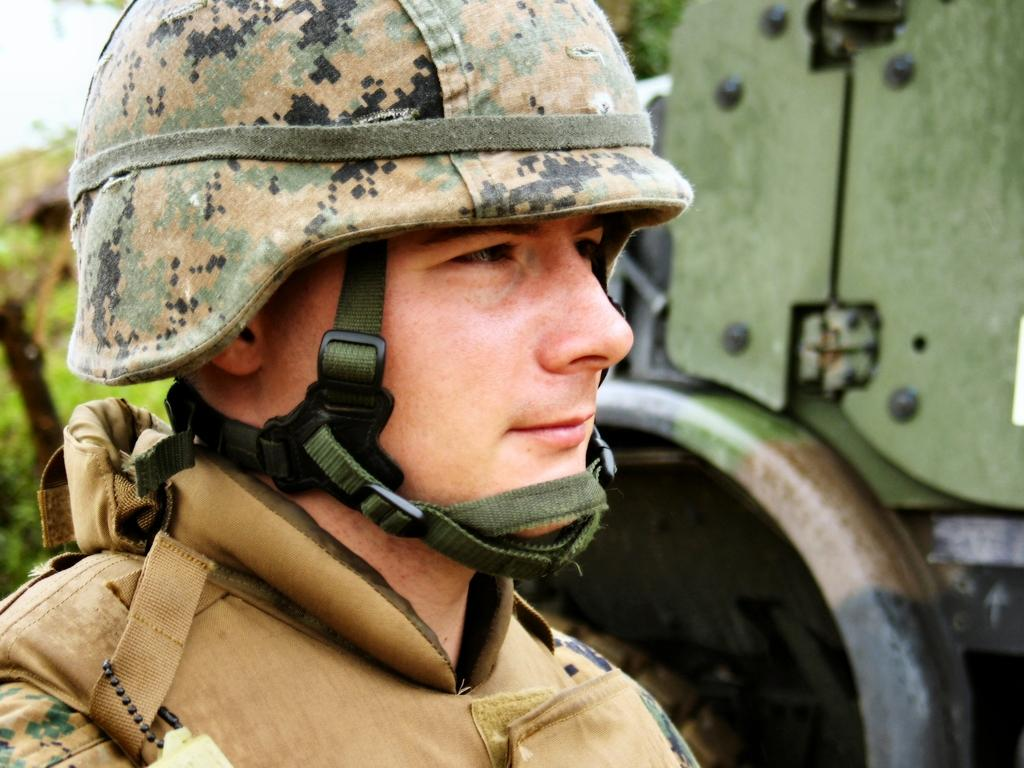Who or what is in the front of the image? There is a person in the front of the image. What can be seen in the background of the image? There is a vehicle and trees in the background of the image. Where is the group of people sleeping in the image? There is no group of people sleeping in the image; it only features a person in the front and a vehicle and trees in the background. 